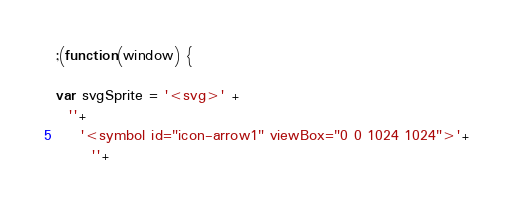Convert code to text. <code><loc_0><loc_0><loc_500><loc_500><_JavaScript_>;(function(window) {

var svgSprite = '<svg>' +
  ''+
    '<symbol id="icon-arrow1" viewBox="0 0 1024 1024">'+
      ''+</code> 